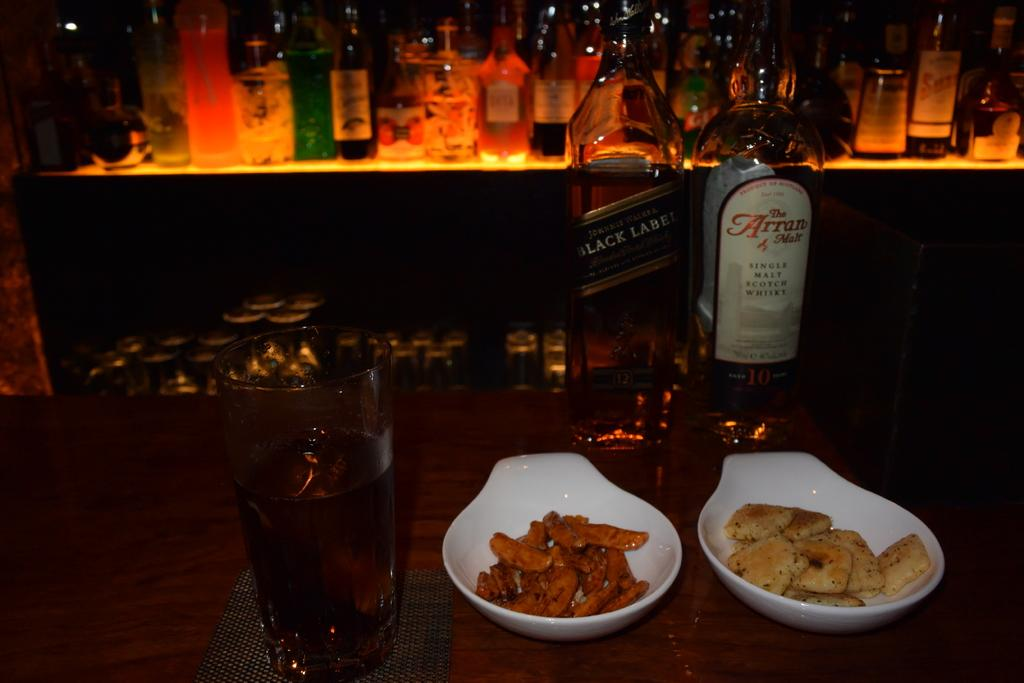<image>
Present a compact description of the photo's key features. A restaurant is serving at the bar with a bottle of Johnnie Walker Black Label. 